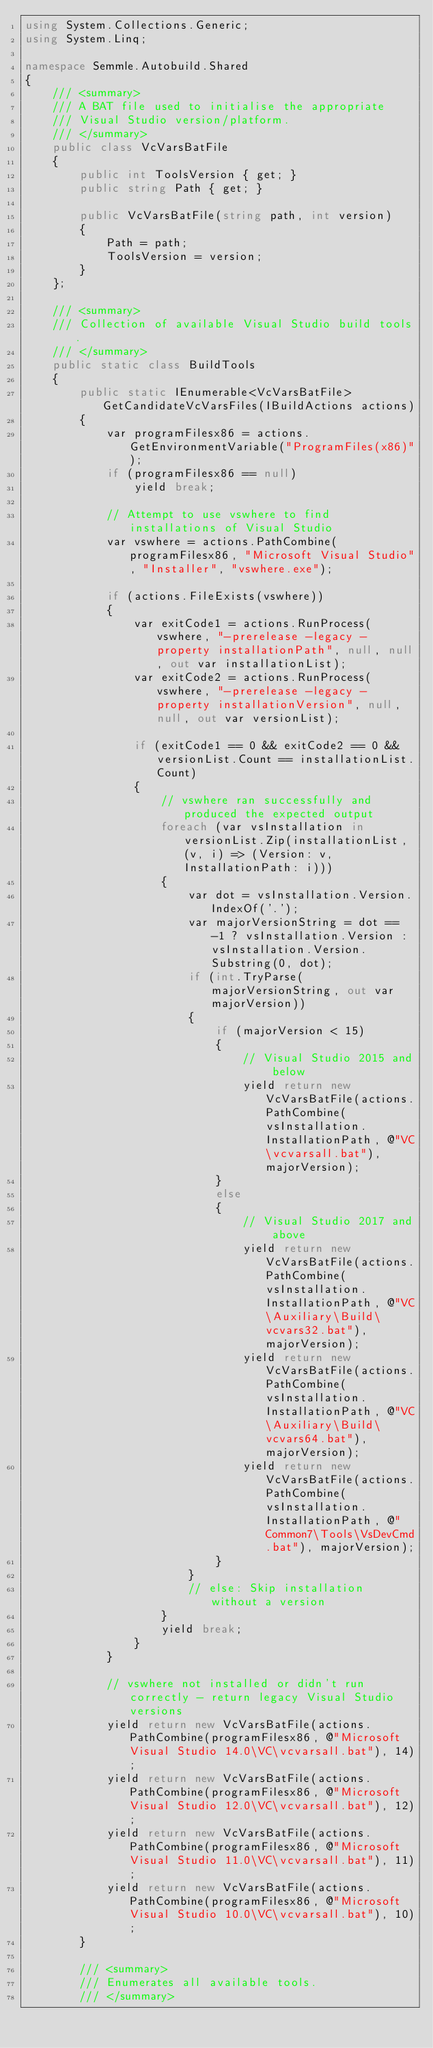Convert code to text. <code><loc_0><loc_0><loc_500><loc_500><_C#_>using System.Collections.Generic;
using System.Linq;

namespace Semmle.Autobuild.Shared
{
    /// <summary>
    /// A BAT file used to initialise the appropriate
    /// Visual Studio version/platform.
    /// </summary>
    public class VcVarsBatFile
    {
        public int ToolsVersion { get; }
        public string Path { get; }

        public VcVarsBatFile(string path, int version)
        {
            Path = path;
            ToolsVersion = version;
        }
    };

    /// <summary>
    /// Collection of available Visual Studio build tools.
    /// </summary>
    public static class BuildTools
    {
        public static IEnumerable<VcVarsBatFile> GetCandidateVcVarsFiles(IBuildActions actions)
        {
            var programFilesx86 = actions.GetEnvironmentVariable("ProgramFiles(x86)");
            if (programFilesx86 == null)
                yield break;

            // Attempt to use vswhere to find installations of Visual Studio
            var vswhere = actions.PathCombine(programFilesx86, "Microsoft Visual Studio", "Installer", "vswhere.exe");

            if (actions.FileExists(vswhere))
            {
                var exitCode1 = actions.RunProcess(vswhere, "-prerelease -legacy -property installationPath", null, null, out var installationList);
                var exitCode2 = actions.RunProcess(vswhere, "-prerelease -legacy -property installationVersion", null, null, out var versionList);

                if (exitCode1 == 0 && exitCode2 == 0 && versionList.Count == installationList.Count)
                {
                    // vswhere ran successfully and produced the expected output
                    foreach (var vsInstallation in versionList.Zip(installationList, (v, i) => (Version: v, InstallationPath: i)))
                    {
                        var dot = vsInstallation.Version.IndexOf('.');
                        var majorVersionString = dot == -1 ? vsInstallation.Version : vsInstallation.Version.Substring(0, dot);
                        if (int.TryParse(majorVersionString, out var majorVersion))
                        {
                            if (majorVersion < 15)
                            {
                                // Visual Studio 2015 and below
                                yield return new VcVarsBatFile(actions.PathCombine(vsInstallation.InstallationPath, @"VC\vcvarsall.bat"), majorVersion);
                            }
                            else
                            {
                                // Visual Studio 2017 and above
                                yield return new VcVarsBatFile(actions.PathCombine(vsInstallation.InstallationPath, @"VC\Auxiliary\Build\vcvars32.bat"), majorVersion);
                                yield return new VcVarsBatFile(actions.PathCombine(vsInstallation.InstallationPath, @"VC\Auxiliary\Build\vcvars64.bat"), majorVersion);
                                yield return new VcVarsBatFile(actions.PathCombine(vsInstallation.InstallationPath, @"Common7\Tools\VsDevCmd.bat"), majorVersion);
                            }
                        }
                        // else: Skip installation without a version
                    }
                    yield break;
                }
            }

            // vswhere not installed or didn't run correctly - return legacy Visual Studio versions
            yield return new VcVarsBatFile(actions.PathCombine(programFilesx86, @"Microsoft Visual Studio 14.0\VC\vcvarsall.bat"), 14);
            yield return new VcVarsBatFile(actions.PathCombine(programFilesx86, @"Microsoft Visual Studio 12.0\VC\vcvarsall.bat"), 12);
            yield return new VcVarsBatFile(actions.PathCombine(programFilesx86, @"Microsoft Visual Studio 11.0\VC\vcvarsall.bat"), 11);
            yield return new VcVarsBatFile(actions.PathCombine(programFilesx86, @"Microsoft Visual Studio 10.0\VC\vcvarsall.bat"), 10);
        }

        /// <summary>
        /// Enumerates all available tools.
        /// </summary></code> 